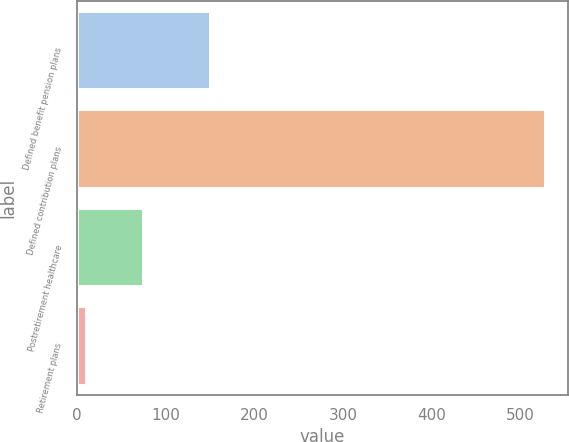Convert chart to OTSL. <chart><loc_0><loc_0><loc_500><loc_500><bar_chart><fcel>Defined benefit pension plans<fcel>Defined contribution plans<fcel>Postretirement healthcare<fcel>Retirement plans<nl><fcel>150<fcel>527<fcel>74<fcel>10<nl></chart> 